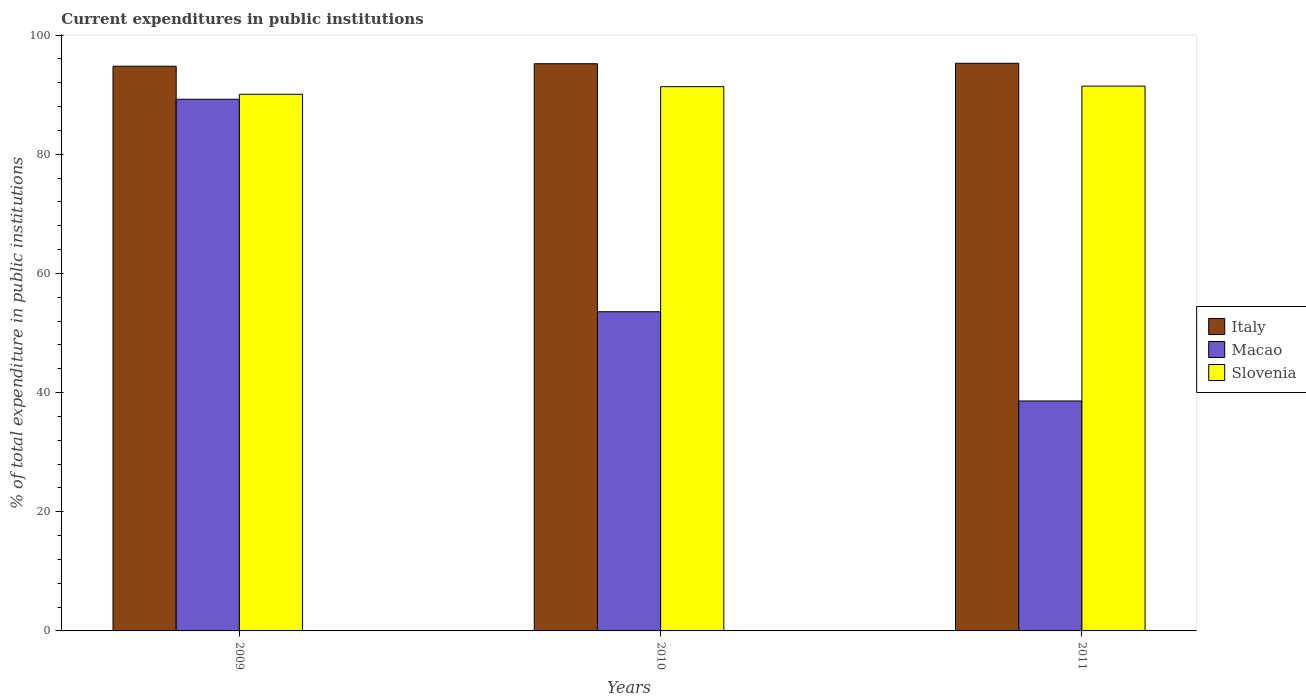How many groups of bars are there?
Your response must be concise. 3. Are the number of bars on each tick of the X-axis equal?
Your answer should be very brief. Yes. How many bars are there on the 2nd tick from the left?
Your response must be concise. 3. What is the label of the 1st group of bars from the left?
Give a very brief answer. 2009. In how many cases, is the number of bars for a given year not equal to the number of legend labels?
Ensure brevity in your answer.  0. What is the current expenditures in public institutions in Italy in 2009?
Make the answer very short. 94.76. Across all years, what is the maximum current expenditures in public institutions in Slovenia?
Provide a succinct answer. 91.42. Across all years, what is the minimum current expenditures in public institutions in Macao?
Your response must be concise. 38.59. In which year was the current expenditures in public institutions in Macao maximum?
Give a very brief answer. 2009. In which year was the current expenditures in public institutions in Italy minimum?
Keep it short and to the point. 2009. What is the total current expenditures in public institutions in Slovenia in the graph?
Keep it short and to the point. 272.82. What is the difference between the current expenditures in public institutions in Italy in 2009 and that in 2010?
Offer a very short reply. -0.41. What is the difference between the current expenditures in public institutions in Macao in 2011 and the current expenditures in public institutions in Slovenia in 2010?
Keep it short and to the point. -52.75. What is the average current expenditures in public institutions in Slovenia per year?
Your answer should be very brief. 90.94. In the year 2011, what is the difference between the current expenditures in public institutions in Macao and current expenditures in public institutions in Slovenia?
Offer a very short reply. -52.84. What is the ratio of the current expenditures in public institutions in Italy in 2009 to that in 2011?
Your answer should be very brief. 0.99. Is the current expenditures in public institutions in Slovenia in 2009 less than that in 2010?
Make the answer very short. Yes. What is the difference between the highest and the second highest current expenditures in public institutions in Macao?
Offer a terse response. 35.65. What is the difference between the highest and the lowest current expenditures in public institutions in Italy?
Give a very brief answer. 0.5. In how many years, is the current expenditures in public institutions in Macao greater than the average current expenditures in public institutions in Macao taken over all years?
Keep it short and to the point. 1. Is the sum of the current expenditures in public institutions in Slovenia in 2009 and 2011 greater than the maximum current expenditures in public institutions in Italy across all years?
Make the answer very short. Yes. What does the 3rd bar from the left in 2010 represents?
Provide a short and direct response. Slovenia. What does the 2nd bar from the right in 2009 represents?
Your answer should be very brief. Macao. How many bars are there?
Your answer should be very brief. 9. What is the title of the graph?
Your response must be concise. Current expenditures in public institutions. Does "Finland" appear as one of the legend labels in the graph?
Your response must be concise. No. What is the label or title of the Y-axis?
Provide a short and direct response. % of total expenditure in public institutions. What is the % of total expenditure in public institutions in Italy in 2009?
Ensure brevity in your answer.  94.76. What is the % of total expenditure in public institutions of Macao in 2009?
Your response must be concise. 89.22. What is the % of total expenditure in public institutions of Slovenia in 2009?
Provide a succinct answer. 90.06. What is the % of total expenditure in public institutions of Italy in 2010?
Offer a very short reply. 95.18. What is the % of total expenditure in public institutions in Macao in 2010?
Keep it short and to the point. 53.56. What is the % of total expenditure in public institutions of Slovenia in 2010?
Give a very brief answer. 91.34. What is the % of total expenditure in public institutions in Italy in 2011?
Your answer should be compact. 95.26. What is the % of total expenditure in public institutions of Macao in 2011?
Give a very brief answer. 38.59. What is the % of total expenditure in public institutions of Slovenia in 2011?
Ensure brevity in your answer.  91.42. Across all years, what is the maximum % of total expenditure in public institutions in Italy?
Provide a short and direct response. 95.26. Across all years, what is the maximum % of total expenditure in public institutions in Macao?
Provide a succinct answer. 89.22. Across all years, what is the maximum % of total expenditure in public institutions of Slovenia?
Offer a very short reply. 91.42. Across all years, what is the minimum % of total expenditure in public institutions of Italy?
Your response must be concise. 94.76. Across all years, what is the minimum % of total expenditure in public institutions of Macao?
Your answer should be very brief. 38.59. Across all years, what is the minimum % of total expenditure in public institutions of Slovenia?
Keep it short and to the point. 90.06. What is the total % of total expenditure in public institutions in Italy in the graph?
Give a very brief answer. 285.2. What is the total % of total expenditure in public institutions of Macao in the graph?
Make the answer very short. 181.37. What is the total % of total expenditure in public institutions in Slovenia in the graph?
Your response must be concise. 272.82. What is the difference between the % of total expenditure in public institutions of Italy in 2009 and that in 2010?
Your answer should be compact. -0.41. What is the difference between the % of total expenditure in public institutions in Macao in 2009 and that in 2010?
Your answer should be very brief. 35.65. What is the difference between the % of total expenditure in public institutions of Slovenia in 2009 and that in 2010?
Your response must be concise. -1.28. What is the difference between the % of total expenditure in public institutions in Italy in 2009 and that in 2011?
Give a very brief answer. -0.5. What is the difference between the % of total expenditure in public institutions in Macao in 2009 and that in 2011?
Your answer should be very brief. 50.63. What is the difference between the % of total expenditure in public institutions in Slovenia in 2009 and that in 2011?
Offer a terse response. -1.36. What is the difference between the % of total expenditure in public institutions of Italy in 2010 and that in 2011?
Give a very brief answer. -0.08. What is the difference between the % of total expenditure in public institutions of Macao in 2010 and that in 2011?
Provide a short and direct response. 14.98. What is the difference between the % of total expenditure in public institutions in Slovenia in 2010 and that in 2011?
Ensure brevity in your answer.  -0.09. What is the difference between the % of total expenditure in public institutions in Italy in 2009 and the % of total expenditure in public institutions in Macao in 2010?
Provide a short and direct response. 41.2. What is the difference between the % of total expenditure in public institutions in Italy in 2009 and the % of total expenditure in public institutions in Slovenia in 2010?
Give a very brief answer. 3.43. What is the difference between the % of total expenditure in public institutions in Macao in 2009 and the % of total expenditure in public institutions in Slovenia in 2010?
Offer a very short reply. -2.12. What is the difference between the % of total expenditure in public institutions in Italy in 2009 and the % of total expenditure in public institutions in Macao in 2011?
Offer a terse response. 56.18. What is the difference between the % of total expenditure in public institutions of Italy in 2009 and the % of total expenditure in public institutions of Slovenia in 2011?
Keep it short and to the point. 3.34. What is the difference between the % of total expenditure in public institutions in Macao in 2009 and the % of total expenditure in public institutions in Slovenia in 2011?
Offer a very short reply. -2.21. What is the difference between the % of total expenditure in public institutions in Italy in 2010 and the % of total expenditure in public institutions in Macao in 2011?
Provide a short and direct response. 56.59. What is the difference between the % of total expenditure in public institutions of Italy in 2010 and the % of total expenditure in public institutions of Slovenia in 2011?
Ensure brevity in your answer.  3.76. What is the difference between the % of total expenditure in public institutions in Macao in 2010 and the % of total expenditure in public institutions in Slovenia in 2011?
Your response must be concise. -37.86. What is the average % of total expenditure in public institutions in Italy per year?
Make the answer very short. 95.07. What is the average % of total expenditure in public institutions in Macao per year?
Offer a very short reply. 60.46. What is the average % of total expenditure in public institutions of Slovenia per year?
Your response must be concise. 90.94. In the year 2009, what is the difference between the % of total expenditure in public institutions of Italy and % of total expenditure in public institutions of Macao?
Provide a succinct answer. 5.55. In the year 2009, what is the difference between the % of total expenditure in public institutions in Italy and % of total expenditure in public institutions in Slovenia?
Your answer should be very brief. 4.71. In the year 2009, what is the difference between the % of total expenditure in public institutions of Macao and % of total expenditure in public institutions of Slovenia?
Offer a very short reply. -0.84. In the year 2010, what is the difference between the % of total expenditure in public institutions in Italy and % of total expenditure in public institutions in Macao?
Your answer should be compact. 41.62. In the year 2010, what is the difference between the % of total expenditure in public institutions of Italy and % of total expenditure in public institutions of Slovenia?
Your answer should be very brief. 3.84. In the year 2010, what is the difference between the % of total expenditure in public institutions in Macao and % of total expenditure in public institutions in Slovenia?
Keep it short and to the point. -37.77. In the year 2011, what is the difference between the % of total expenditure in public institutions in Italy and % of total expenditure in public institutions in Macao?
Your response must be concise. 56.67. In the year 2011, what is the difference between the % of total expenditure in public institutions in Italy and % of total expenditure in public institutions in Slovenia?
Provide a succinct answer. 3.84. In the year 2011, what is the difference between the % of total expenditure in public institutions of Macao and % of total expenditure in public institutions of Slovenia?
Offer a very short reply. -52.84. What is the ratio of the % of total expenditure in public institutions of Macao in 2009 to that in 2010?
Your response must be concise. 1.67. What is the ratio of the % of total expenditure in public institutions in Italy in 2009 to that in 2011?
Ensure brevity in your answer.  0.99. What is the ratio of the % of total expenditure in public institutions of Macao in 2009 to that in 2011?
Offer a terse response. 2.31. What is the ratio of the % of total expenditure in public institutions in Slovenia in 2009 to that in 2011?
Ensure brevity in your answer.  0.99. What is the ratio of the % of total expenditure in public institutions in Macao in 2010 to that in 2011?
Give a very brief answer. 1.39. What is the difference between the highest and the second highest % of total expenditure in public institutions in Italy?
Provide a short and direct response. 0.08. What is the difference between the highest and the second highest % of total expenditure in public institutions of Macao?
Provide a succinct answer. 35.65. What is the difference between the highest and the second highest % of total expenditure in public institutions in Slovenia?
Offer a very short reply. 0.09. What is the difference between the highest and the lowest % of total expenditure in public institutions of Italy?
Keep it short and to the point. 0.5. What is the difference between the highest and the lowest % of total expenditure in public institutions in Macao?
Offer a terse response. 50.63. What is the difference between the highest and the lowest % of total expenditure in public institutions in Slovenia?
Offer a very short reply. 1.36. 